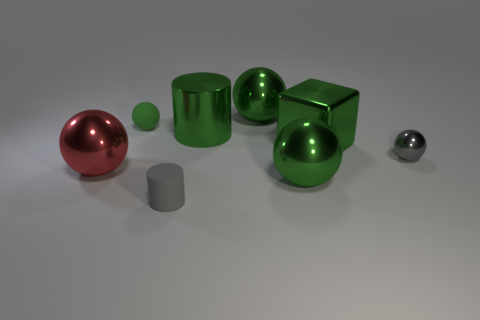What number of other things are there of the same material as the green cube
Your response must be concise. 5. There is a big metallic object on the left side of the green thing on the left side of the tiny cylinder; what number of big green metallic things are behind it?
Make the answer very short. 3. How many shiny objects are either small gray cylinders or large red objects?
Provide a succinct answer. 1. There is a gray object that is to the left of the big metal ball behind the small gray shiny ball; how big is it?
Provide a short and direct response. Small. There is a small object that is behind the big green metallic cylinder; is it the same color as the big thing to the left of the tiny gray matte object?
Offer a very short reply. No. There is a small thing that is both behind the gray matte thing and right of the green rubber ball; what color is it?
Your answer should be very brief. Gray. Does the gray ball have the same material as the big cube?
Offer a very short reply. Yes. How many big objects are either green rubber objects or red matte blocks?
Offer a terse response. 0. Is there any other thing that is the same shape as the tiny gray metallic thing?
Ensure brevity in your answer.  Yes. Are there any other things that are the same size as the red object?
Give a very brief answer. Yes. 